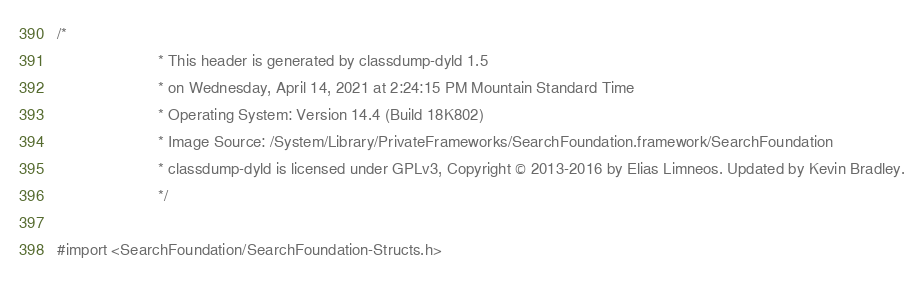Convert code to text. <code><loc_0><loc_0><loc_500><loc_500><_C_>/*
                       * This header is generated by classdump-dyld 1.5
                       * on Wednesday, April 14, 2021 at 2:24:15 PM Mountain Standard Time
                       * Operating System: Version 14.4 (Build 18K802)
                       * Image Source: /System/Library/PrivateFrameworks/SearchFoundation.framework/SearchFoundation
                       * classdump-dyld is licensed under GPLv3, Copyright © 2013-2016 by Elias Limneos. Updated by Kevin Bradley.
                       */

#import <SearchFoundation/SearchFoundation-Structs.h></code> 